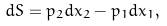Convert formula to latex. <formula><loc_0><loc_0><loc_500><loc_500>d S = p _ { 2 } d x _ { 2 } - p _ { 1 } d x _ { 1 } ,</formula> 